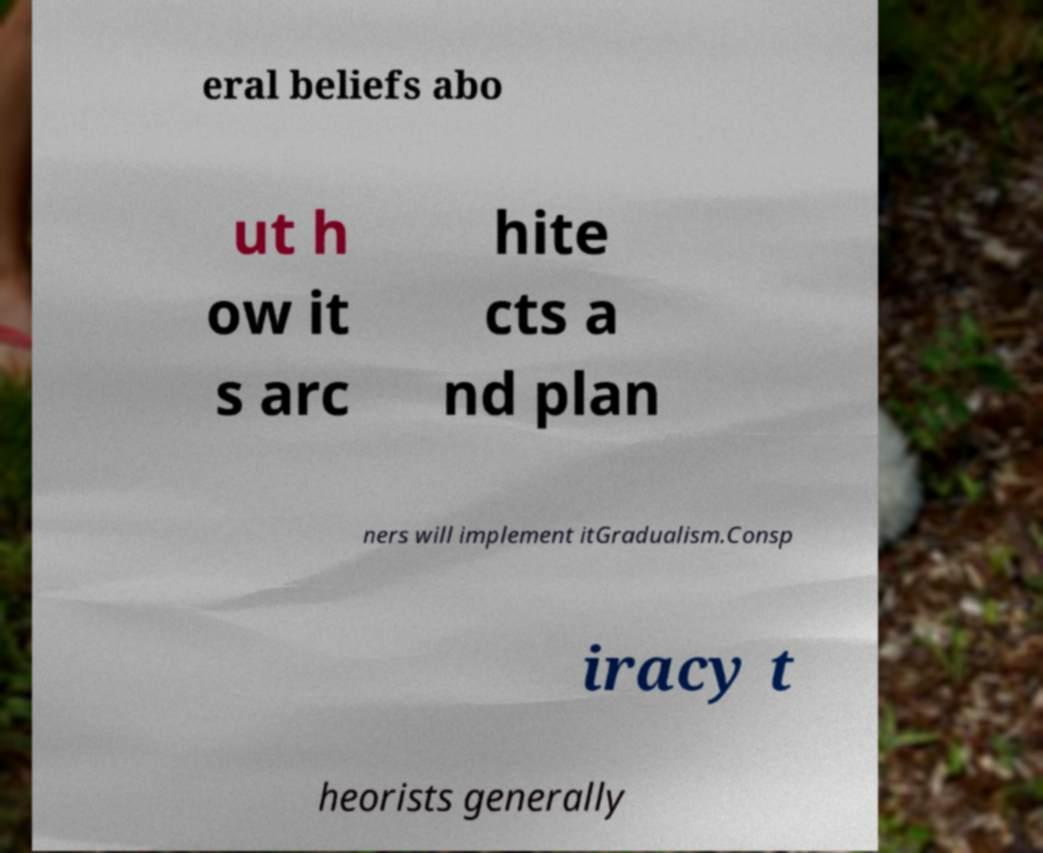There's text embedded in this image that I need extracted. Can you transcribe it verbatim? eral beliefs abo ut h ow it s arc hite cts a nd plan ners will implement itGradualism.Consp iracy t heorists generally 